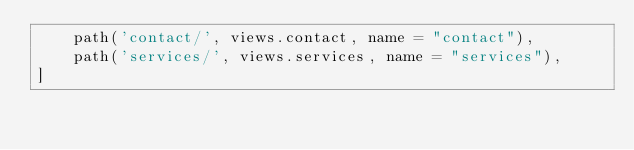<code> <loc_0><loc_0><loc_500><loc_500><_Python_>    path('contact/', views.contact, name = "contact"),
    path('services/', views.services, name = "services"),
]
</code> 